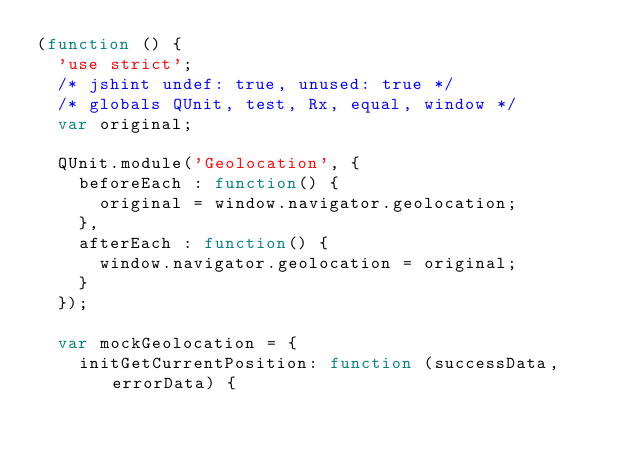Convert code to text. <code><loc_0><loc_0><loc_500><loc_500><_JavaScript_>(function () {
  'use strict';
  /* jshint undef: true, unused: true */
  /* globals QUnit, test, Rx, equal, window */
  var original;

  QUnit.module('Geolocation', {
    beforeEach : function() {
      original = window.navigator.geolocation;
    },
    afterEach : function() {
      window.navigator.geolocation = original;
    }
  });

  var mockGeolocation = {
    initGetCurrentPosition: function (successData, errorData) {</code> 